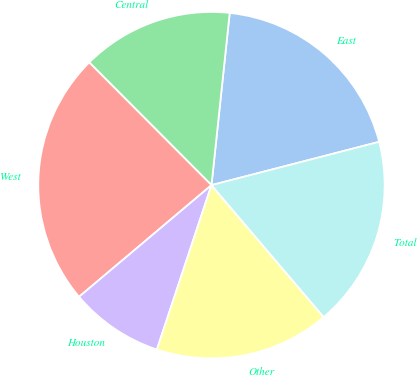Convert chart to OTSL. <chart><loc_0><loc_0><loc_500><loc_500><pie_chart><fcel>East<fcel>Central<fcel>West<fcel>Houston<fcel>Other<fcel>Total<nl><fcel>19.3%<fcel>14.15%<fcel>23.68%<fcel>8.75%<fcel>16.32%<fcel>17.81%<nl></chart> 